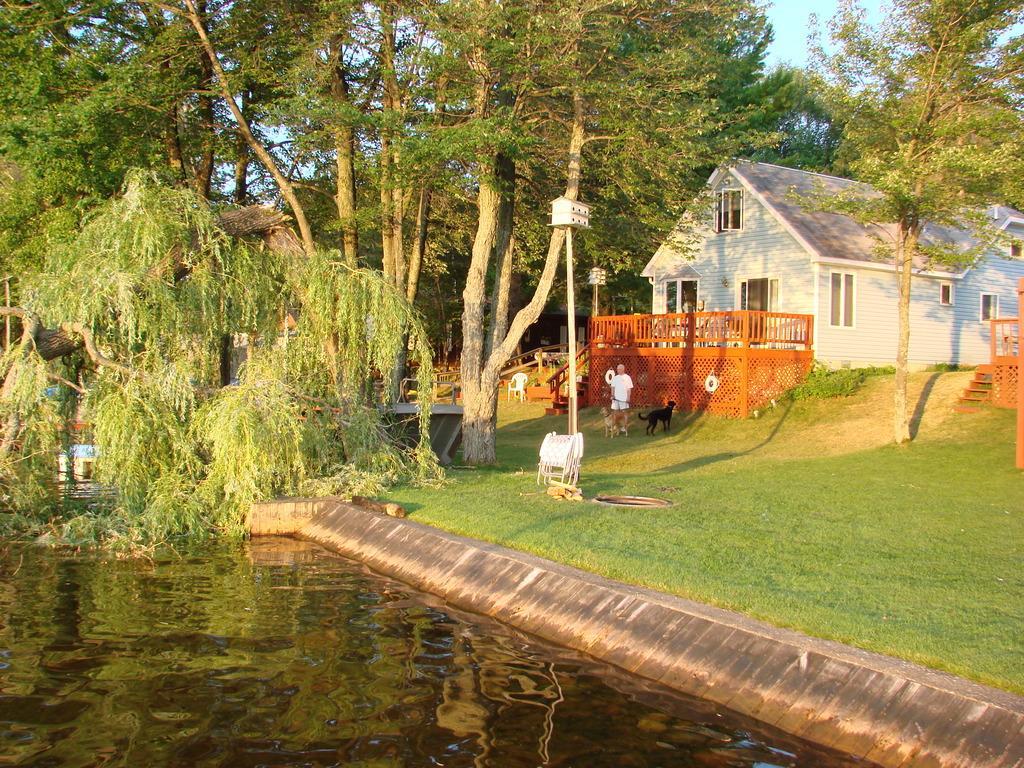In one or two sentences, can you explain what this image depicts? In this image, we can see a house in between trees. There is canal at the bottom of the image. There is a person and dogs in the middle of the image. 